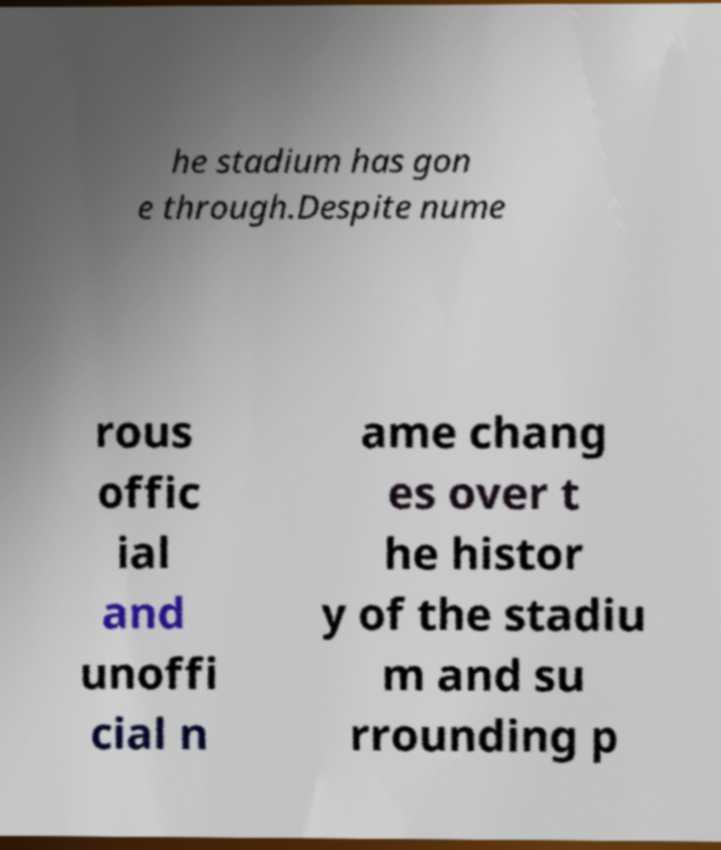What messages or text are displayed in this image? I need them in a readable, typed format. he stadium has gon e through.Despite nume rous offic ial and unoffi cial n ame chang es over t he histor y of the stadiu m and su rrounding p 